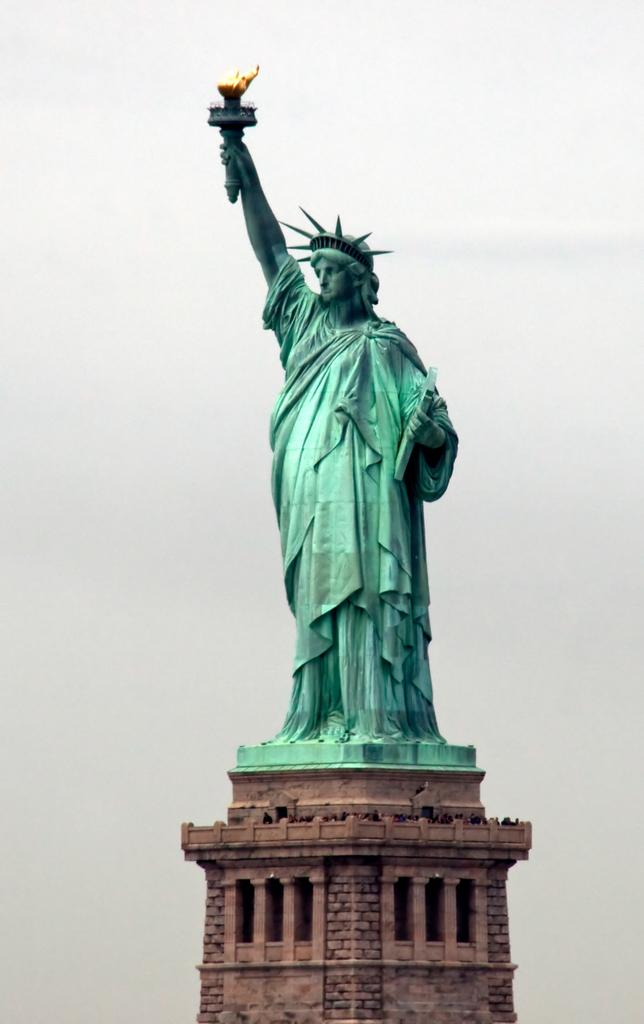What famous landmark can be seen in the image? The Statue of Liberty is present in the image. What can be seen in the background of the image? The sky is visible in the background of the image. What type of quill is the Statue of Liberty holding in the image? The Statue of Liberty is not holding a quill in the image; it is holding a torch. 